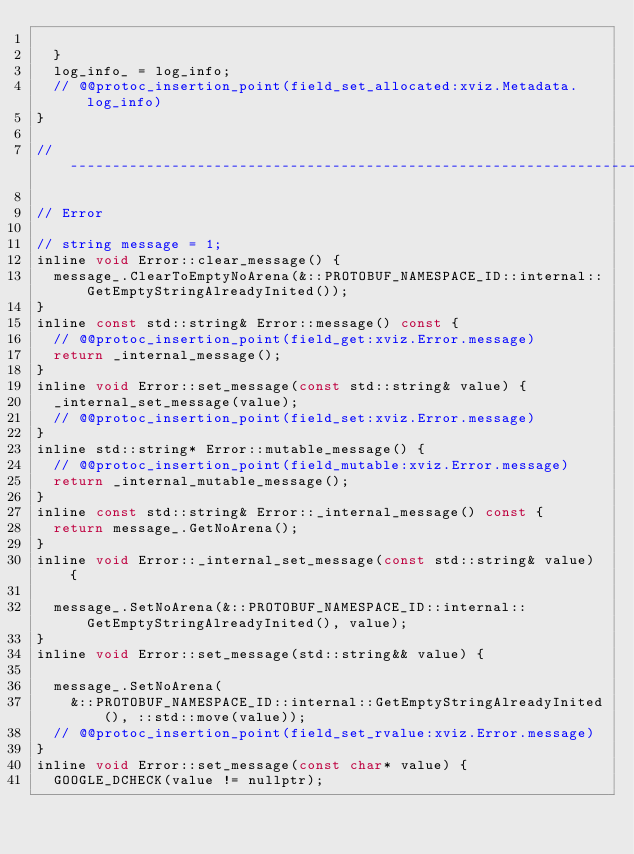Convert code to text. <code><loc_0><loc_0><loc_500><loc_500><_C_>    
  }
  log_info_ = log_info;
  // @@protoc_insertion_point(field_set_allocated:xviz.Metadata.log_info)
}

// -------------------------------------------------------------------

// Error

// string message = 1;
inline void Error::clear_message() {
  message_.ClearToEmptyNoArena(&::PROTOBUF_NAMESPACE_ID::internal::GetEmptyStringAlreadyInited());
}
inline const std::string& Error::message() const {
  // @@protoc_insertion_point(field_get:xviz.Error.message)
  return _internal_message();
}
inline void Error::set_message(const std::string& value) {
  _internal_set_message(value);
  // @@protoc_insertion_point(field_set:xviz.Error.message)
}
inline std::string* Error::mutable_message() {
  // @@protoc_insertion_point(field_mutable:xviz.Error.message)
  return _internal_mutable_message();
}
inline const std::string& Error::_internal_message() const {
  return message_.GetNoArena();
}
inline void Error::_internal_set_message(const std::string& value) {
  
  message_.SetNoArena(&::PROTOBUF_NAMESPACE_ID::internal::GetEmptyStringAlreadyInited(), value);
}
inline void Error::set_message(std::string&& value) {
  
  message_.SetNoArena(
    &::PROTOBUF_NAMESPACE_ID::internal::GetEmptyStringAlreadyInited(), ::std::move(value));
  // @@protoc_insertion_point(field_set_rvalue:xviz.Error.message)
}
inline void Error::set_message(const char* value) {
  GOOGLE_DCHECK(value != nullptr);
  </code> 